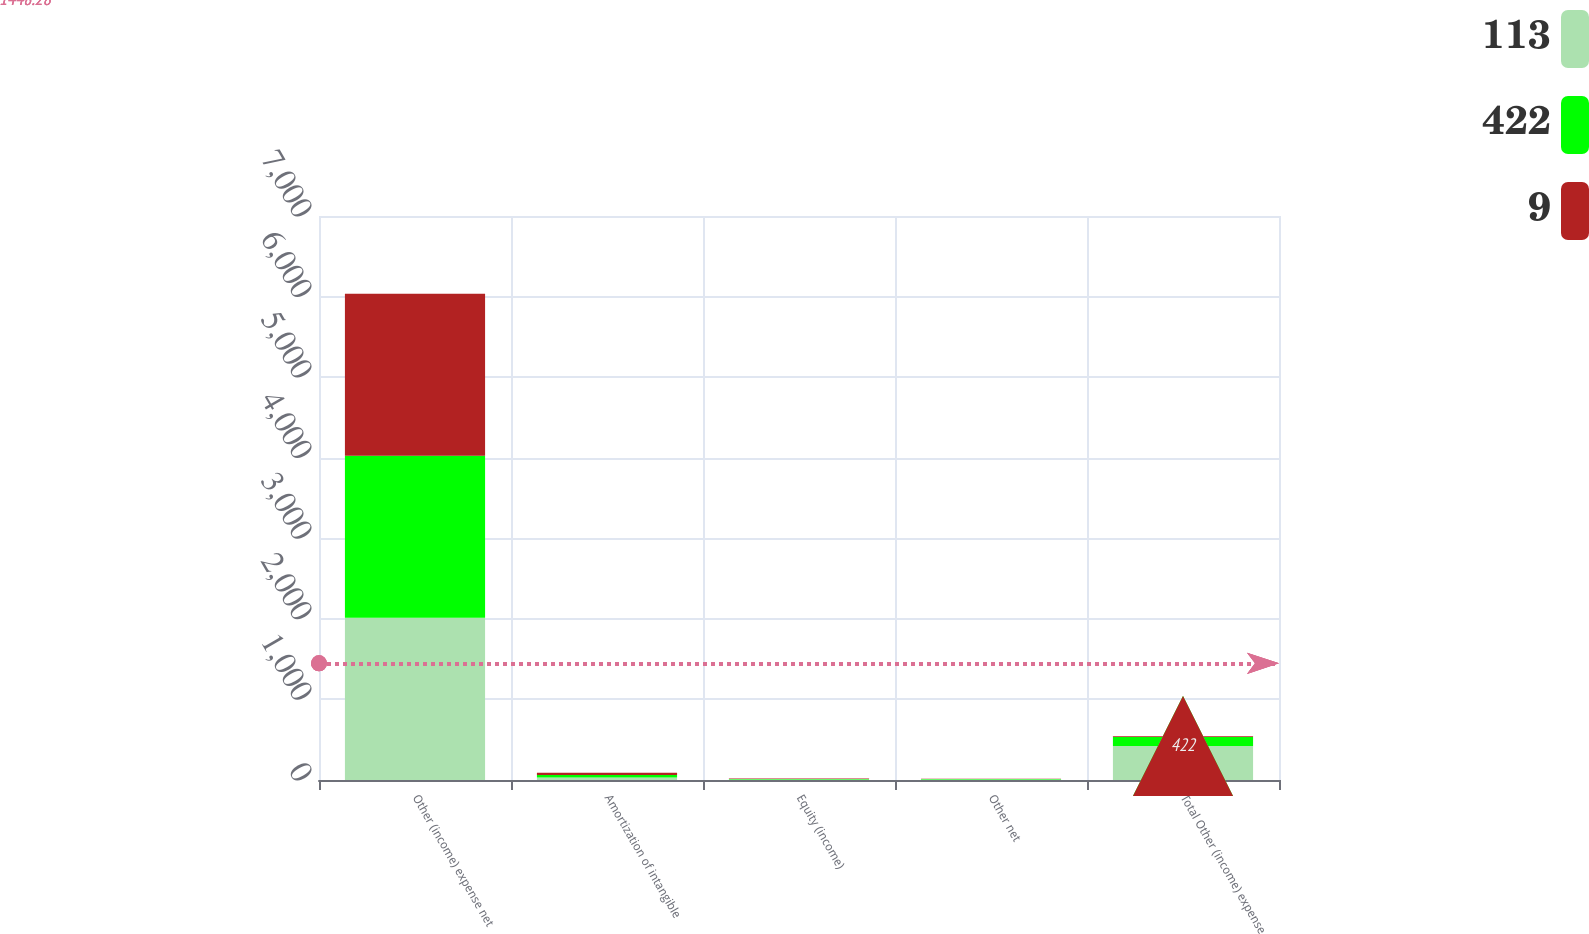<chart> <loc_0><loc_0><loc_500><loc_500><stacked_bar_chart><ecel><fcel>Other (income) expense net<fcel>Amortization of intangible<fcel>Equity (income)<fcel>Other net<fcel>Total Other (income) expense<nl><fcel>113<fcel>2013<fcel>32<fcel>5<fcel>5<fcel>422<nl><fcel>422<fcel>2012<fcel>31<fcel>7<fcel>6<fcel>113<nl><fcel>9<fcel>2011<fcel>28<fcel>6<fcel>6<fcel>9<nl></chart> 